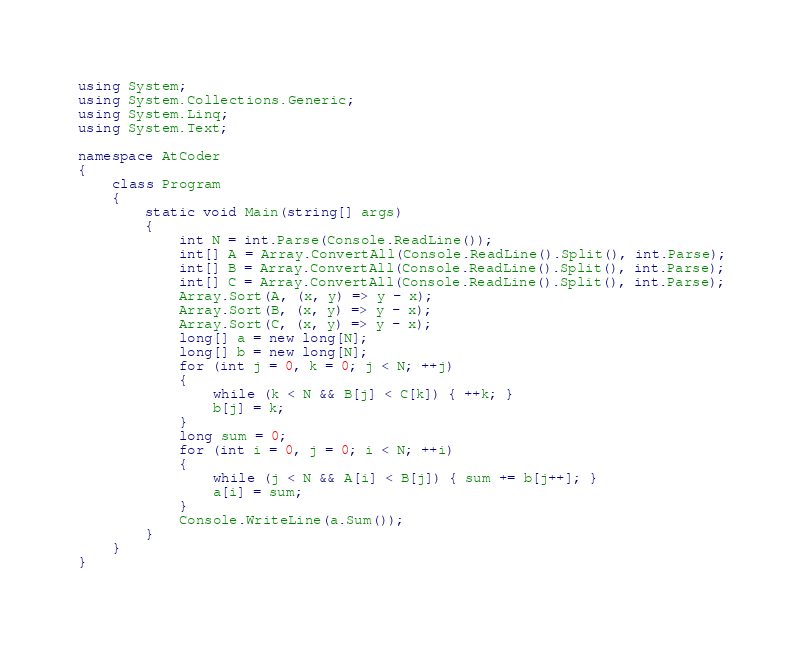Convert code to text. <code><loc_0><loc_0><loc_500><loc_500><_C#_>using System;
using System.Collections.Generic;
using System.Linq;
using System.Text;

namespace AtCoder
{
    class Program
    {
        static void Main(string[] args)
        {
            int N = int.Parse(Console.ReadLine());
            int[] A = Array.ConvertAll(Console.ReadLine().Split(), int.Parse);
            int[] B = Array.ConvertAll(Console.ReadLine().Split(), int.Parse);
            int[] C = Array.ConvertAll(Console.ReadLine().Split(), int.Parse);
            Array.Sort(A, (x, y) => y - x);
            Array.Sort(B, (x, y) => y - x);
            Array.Sort(C, (x, y) => y - x);
            long[] a = new long[N];
            long[] b = new long[N];
            for (int j = 0, k = 0; j < N; ++j)
            {
                while (k < N && B[j] < C[k]) { ++k; }
                b[j] = k;
            }
            long sum = 0;
            for (int i = 0, j = 0; i < N; ++i)
            {
                while (j < N && A[i] < B[j]) { sum += b[j++]; }
                a[i] = sum;
            }
            Console.WriteLine(a.Sum());
        }
    }
}
</code> 